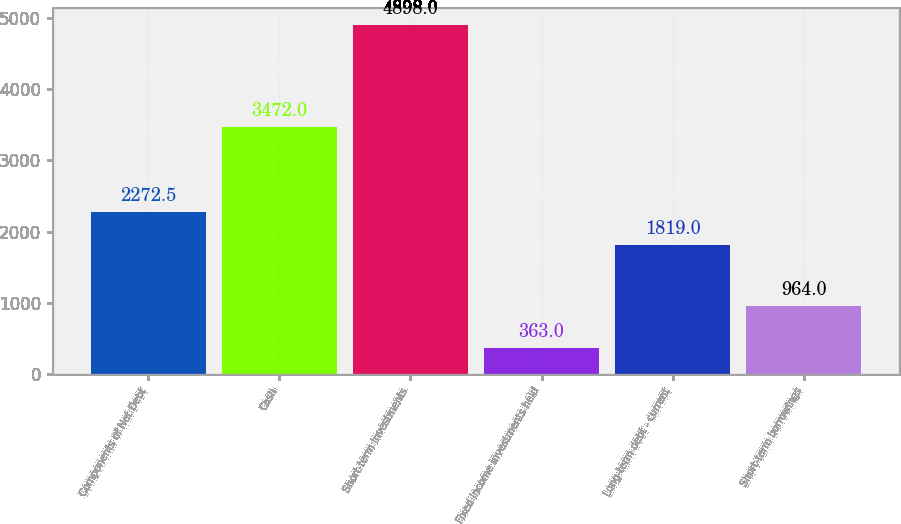<chart> <loc_0><loc_0><loc_500><loc_500><bar_chart><fcel>Components of Net Debt<fcel>Cash<fcel>Short-term investments<fcel>Fixed income investments held<fcel>Long-term debt - current<fcel>Short-term borrowings<nl><fcel>2272.5<fcel>3472<fcel>4898<fcel>363<fcel>1819<fcel>964<nl></chart> 